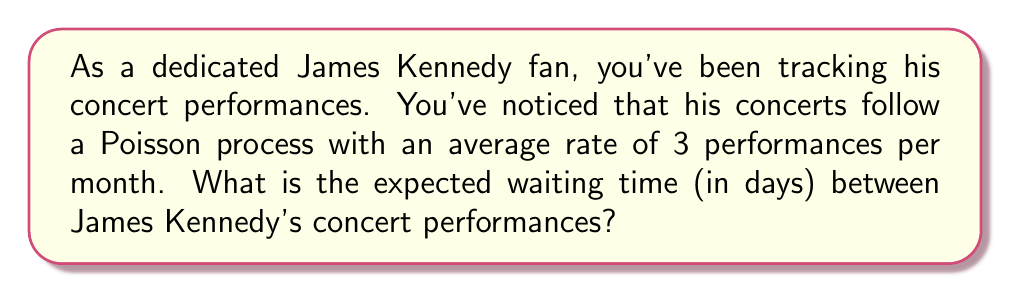Help me with this question. Let's approach this step-by-step:

1) First, we need to understand what the given information means:
   - The concerts follow a Poisson process
   - The rate (λ) is 3 performances per month

2) In a Poisson process, the time between events (in this case, concerts) follows an exponential distribution.

3) For an exponential distribution, the expected value (mean) is given by:

   $$ E[X] = \frac{1}{\lambda} $$

   where λ is the rate parameter.

4) We're given λ = 3 per month, but we want the answer in days. So we need to convert:

   λ (per day) = 3 / 30 = 0.1 per day

5) Now we can calculate the expected waiting time:

   $$ E[X] = \frac{1}{\lambda} = \frac{1}{0.1} = 10 \text{ days} $$

Therefore, the expected waiting time between James Kennedy's concert performances is 10 days.
Answer: 10 days 